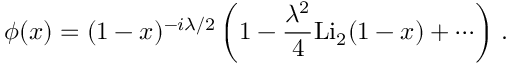<formula> <loc_0><loc_0><loc_500><loc_500>\phi ( x ) = ( 1 - x ) ^ { - i \lambda / 2 } \left ( 1 - \frac { \lambda ^ { 2 } } { 4 } L i _ { 2 } ( 1 - x ) + \cdots \right ) \, .</formula> 